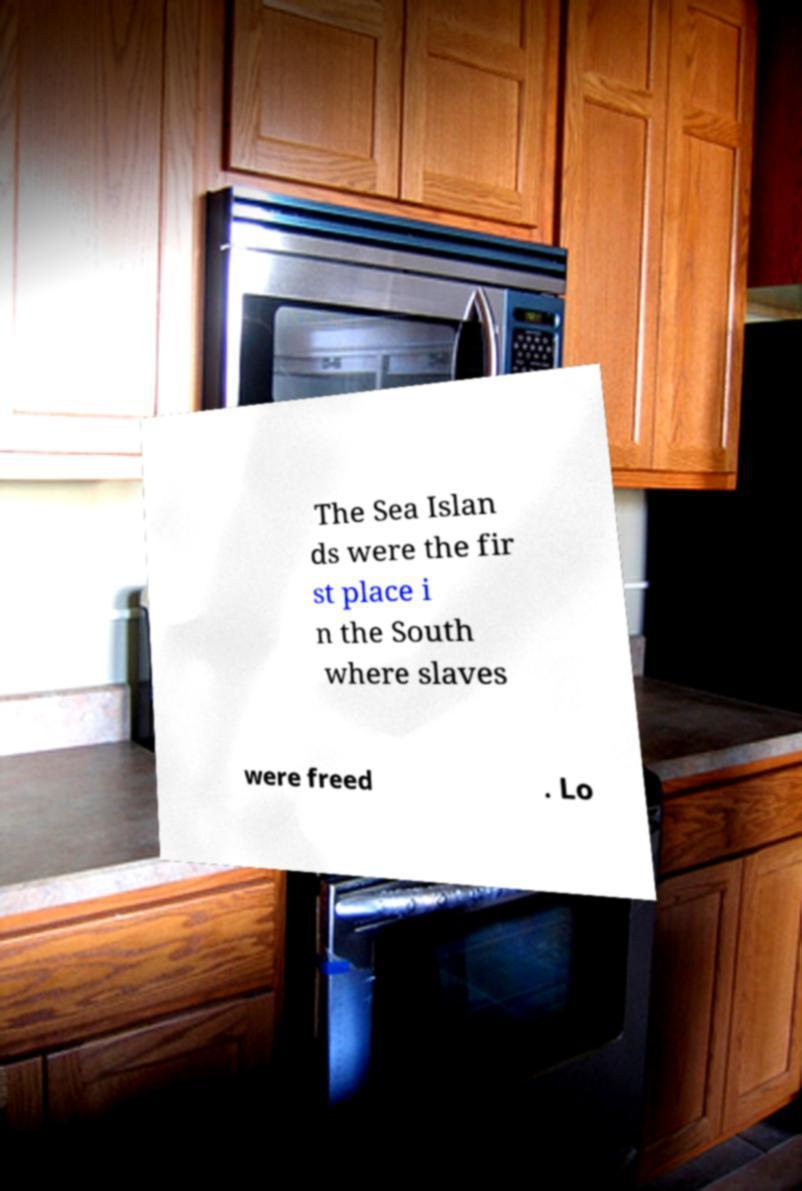There's text embedded in this image that I need extracted. Can you transcribe it verbatim? The Sea Islan ds were the fir st place i n the South where slaves were freed . Lo 